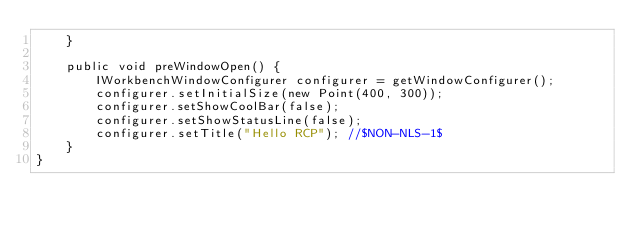<code> <loc_0><loc_0><loc_500><loc_500><_Java_>    }
    
    public void preWindowOpen() {
        IWorkbenchWindowConfigurer configurer = getWindowConfigurer();
        configurer.setInitialSize(new Point(400, 300));
        configurer.setShowCoolBar(false);
        configurer.setShowStatusLine(false);
        configurer.setTitle("Hello RCP"); //$NON-NLS-1$
    }
}
</code> 